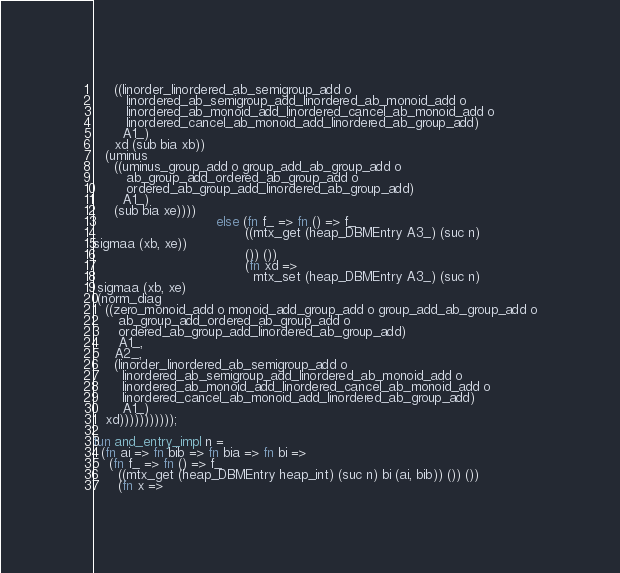Convert code to text. <code><loc_0><loc_0><loc_500><loc_500><_SML_>     ((linorder_linordered_ab_semigroup_add o
        linordered_ab_semigroup_add_linordered_ab_monoid_add o
        linordered_ab_monoid_add_linordered_cancel_ab_monoid_add o
        linordered_cancel_ab_monoid_add_linordered_ab_group_add)
       A1_)
     xd (sub bia xb))
   (uminus
     ((uminus_group_add o group_add_ab_group_add o
        ab_group_add_ordered_ab_group_add o
        ordered_ab_group_add_linordered_ab_group_add)
       A1_)
     (sub bia xe))))
                              else (fn f_ => fn () => f_
                                     ((mtx_get (heap_DBMEntry A3_) (suc n)
sigmaa (xb, xe))
                                     ()) ())
                                     (fn xd =>
                                       mtx_set (heap_DBMEntry A3_) (suc n)
 sigmaa (xb, xe)
 (norm_diag
   ((zero_monoid_add o monoid_add_group_add o group_add_ab_group_add o
      ab_group_add_ordered_ab_group_add o
      ordered_ab_group_add_linordered_ab_group_add)
      A1_,
     A2_,
     (linorder_linordered_ab_semigroup_add o
       linordered_ab_semigroup_add_linordered_ab_monoid_add o
       linordered_ab_monoid_add_linordered_cancel_ab_monoid_add o
       linordered_cancel_ab_monoid_add_linordered_ab_group_add)
       A1_)
   xd)))))))))));

fun and_entry_impl n =
  (fn ai => fn bib => fn bia => fn bi =>
    (fn f_ => fn () => f_
      ((mtx_get (heap_DBMEntry heap_int) (suc n) bi (ai, bib)) ()) ())
      (fn x =></code> 